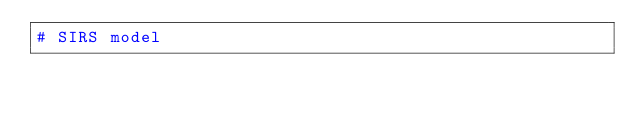Convert code to text. <code><loc_0><loc_0><loc_500><loc_500><_Python_># SIRS model
</code> 